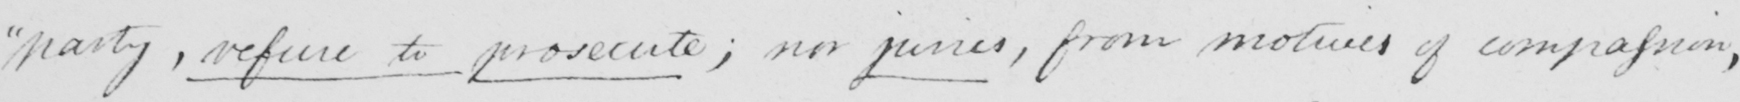What text is written in this handwritten line? " party , refuse to prosecute ; nor juries , from motives of compassion , 